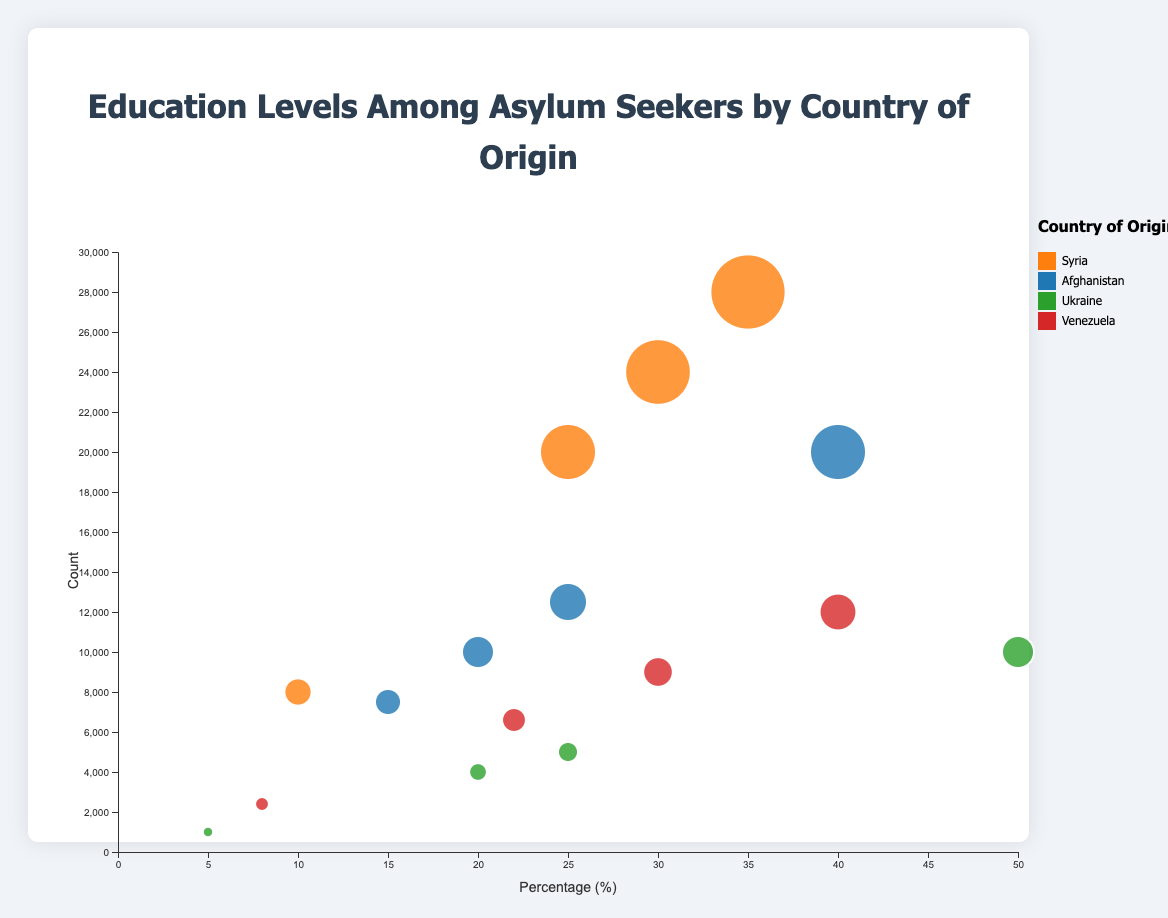What is the percentage of asylum seekers from Syria with primary education? Locate the data points for Syria. Look for the bubble representing primary education and read off the percentage label.
Answer: 35% How many asylum seekers from Afghanistan have secondary education? Find the data points for Afghanistan. Identify the bubble for secondary education and read off the count value.
Answer: 10,000 Compare the tertiary education percentages between Venezuela and Ukraine. Which country has a higher percentage? Identify the bubbles for tertiary education in both Venezuela and Ukraine. Compare the percentage values. Venezuela has 22%, Ukraine has 25%, so Ukraine has a higher percentage.
Answer: Ukraine Which country has the lowest number of asylum seekers with no formal education? Find and compare the bubbles for no formal education across all countries. The country with the smallest count is Ukraine with 1,000 asylum seekers.
Answer: Ukraine What is the sum of asylum seekers from Syria with secondary and tertiary education? Find the count for secondary and tertiary education for Syria. Add the values: 24,000 (Secondary) + 20,000 (Tertiary) = 44,000
Answer: 44,000 In which country is the percentage of primary education among asylum seekers exactly 30%? Locate the primary education bubbles. Check the percentages and find the one with exactly 30%. It belongs to Venezuela.
Answer: Venezuela How does the count of asylum seekers with no formal education in Afghanistan compare to that in Syria? Identify the counts for no formal education for both countries. Afghanistan has 12,500, and Syria has 8,000. Afghanistan's count is higher.
Answer: Afghanistan Which country has the highest percentage of asylum seekers with secondary education? Look at the secondary education bubbles and find the highest percentage. Ukraine has the highest at 50%.
Answer: Ukraine Calculate the average count of tertiary educated asylum seekers across all countries. Add the counts of tertiary education for all countries and divide by the number of countries: (20,000 (Syria) + 7,500 (Afghanistan) + 5,000 (Ukraine) + 6,600 (Venezuela)) / 4 = 39,100 / 4 = 9,775
Answer: 9,775 What is the total number of asylum seekers from all countries combined? Sum the count values for all education levels and countries.
Answer: 151,000 